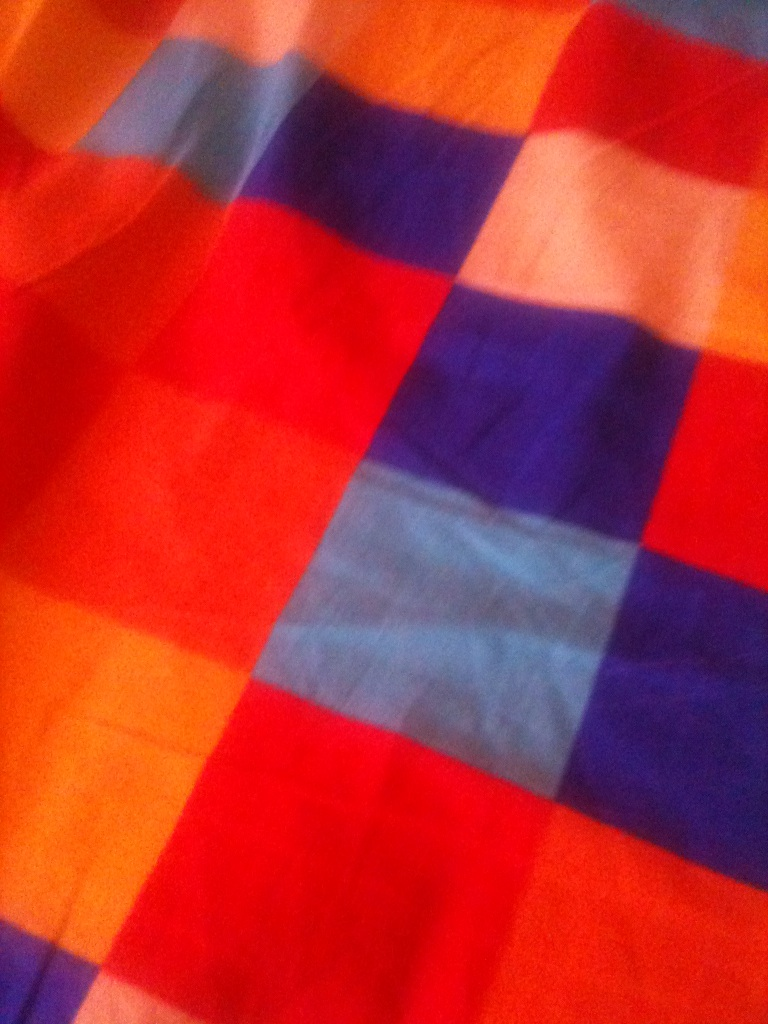Please tell me what color is it? The image predominantly features a pattern with vibrant colors, including shades of red, blue, orange, and a hint of pink or purple. The colors are arranged in a checkered pattern, adding a lively and cheerful aesthetic. 